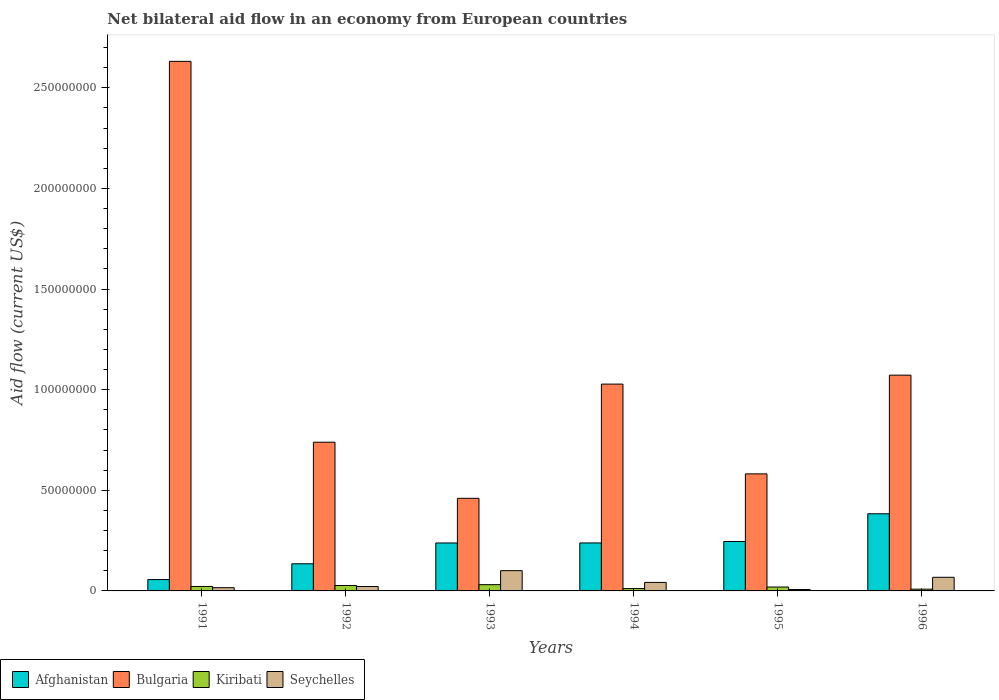How many groups of bars are there?
Your response must be concise. 6. Are the number of bars per tick equal to the number of legend labels?
Your response must be concise. Yes. How many bars are there on the 1st tick from the right?
Your answer should be very brief. 4. What is the label of the 3rd group of bars from the left?
Your answer should be compact. 1993. In how many cases, is the number of bars for a given year not equal to the number of legend labels?
Ensure brevity in your answer.  0. What is the net bilateral aid flow in Kiribati in 1996?
Ensure brevity in your answer.  8.70e+05. Across all years, what is the maximum net bilateral aid flow in Seychelles?
Ensure brevity in your answer.  1.01e+07. Across all years, what is the minimum net bilateral aid flow in Kiribati?
Provide a succinct answer. 8.70e+05. In which year was the net bilateral aid flow in Afghanistan maximum?
Provide a short and direct response. 1996. What is the total net bilateral aid flow in Afghanistan in the graph?
Give a very brief answer. 1.30e+08. What is the difference between the net bilateral aid flow in Afghanistan in 1991 and that in 1993?
Your answer should be very brief. -1.82e+07. What is the difference between the net bilateral aid flow in Seychelles in 1993 and the net bilateral aid flow in Afghanistan in 1994?
Keep it short and to the point. -1.38e+07. What is the average net bilateral aid flow in Kiribati per year?
Make the answer very short. 2.00e+06. In the year 1993, what is the difference between the net bilateral aid flow in Seychelles and net bilateral aid flow in Afghanistan?
Offer a terse response. -1.38e+07. In how many years, is the net bilateral aid flow in Kiribati greater than 40000000 US$?
Offer a terse response. 0. What is the ratio of the net bilateral aid flow in Kiribati in 1991 to that in 1995?
Provide a succinct answer. 1.14. What is the difference between the highest and the second highest net bilateral aid flow in Bulgaria?
Provide a short and direct response. 1.56e+08. What is the difference between the highest and the lowest net bilateral aid flow in Kiribati?
Provide a short and direct response. 2.24e+06. Is the sum of the net bilateral aid flow in Kiribati in 1992 and 1996 greater than the maximum net bilateral aid flow in Afghanistan across all years?
Keep it short and to the point. No. Is it the case that in every year, the sum of the net bilateral aid flow in Afghanistan and net bilateral aid flow in Kiribati is greater than the sum of net bilateral aid flow in Seychelles and net bilateral aid flow in Bulgaria?
Give a very brief answer. No. What does the 1st bar from the left in 1993 represents?
Offer a very short reply. Afghanistan. What does the 3rd bar from the right in 1993 represents?
Give a very brief answer. Bulgaria. How many years are there in the graph?
Keep it short and to the point. 6. What is the difference between two consecutive major ticks on the Y-axis?
Keep it short and to the point. 5.00e+07. What is the title of the graph?
Ensure brevity in your answer.  Net bilateral aid flow in an economy from European countries. What is the label or title of the X-axis?
Offer a very short reply. Years. What is the label or title of the Y-axis?
Provide a short and direct response. Aid flow (current US$). What is the Aid flow (current US$) of Afghanistan in 1991?
Provide a short and direct response. 5.64e+06. What is the Aid flow (current US$) in Bulgaria in 1991?
Provide a short and direct response. 2.63e+08. What is the Aid flow (current US$) of Kiribati in 1991?
Your response must be concise. 2.22e+06. What is the Aid flow (current US$) of Seychelles in 1991?
Provide a succinct answer. 1.61e+06. What is the Aid flow (current US$) in Afghanistan in 1992?
Your response must be concise. 1.35e+07. What is the Aid flow (current US$) in Bulgaria in 1992?
Your answer should be very brief. 7.39e+07. What is the Aid flow (current US$) in Kiribati in 1992?
Give a very brief answer. 2.69e+06. What is the Aid flow (current US$) of Seychelles in 1992?
Your answer should be very brief. 2.19e+06. What is the Aid flow (current US$) of Afghanistan in 1993?
Provide a succinct answer. 2.38e+07. What is the Aid flow (current US$) of Bulgaria in 1993?
Provide a succinct answer. 4.60e+07. What is the Aid flow (current US$) of Kiribati in 1993?
Provide a short and direct response. 3.11e+06. What is the Aid flow (current US$) in Seychelles in 1993?
Provide a succinct answer. 1.01e+07. What is the Aid flow (current US$) of Afghanistan in 1994?
Give a very brief answer. 2.38e+07. What is the Aid flow (current US$) in Bulgaria in 1994?
Provide a short and direct response. 1.03e+08. What is the Aid flow (current US$) of Kiribati in 1994?
Your answer should be very brief. 1.16e+06. What is the Aid flow (current US$) in Seychelles in 1994?
Ensure brevity in your answer.  4.23e+06. What is the Aid flow (current US$) of Afghanistan in 1995?
Give a very brief answer. 2.46e+07. What is the Aid flow (current US$) of Bulgaria in 1995?
Provide a succinct answer. 5.82e+07. What is the Aid flow (current US$) of Kiribati in 1995?
Your response must be concise. 1.94e+06. What is the Aid flow (current US$) in Seychelles in 1995?
Your answer should be compact. 7.10e+05. What is the Aid flow (current US$) in Afghanistan in 1996?
Give a very brief answer. 3.83e+07. What is the Aid flow (current US$) of Bulgaria in 1996?
Ensure brevity in your answer.  1.07e+08. What is the Aid flow (current US$) of Kiribati in 1996?
Your answer should be very brief. 8.70e+05. What is the Aid flow (current US$) in Seychelles in 1996?
Your answer should be very brief. 6.77e+06. Across all years, what is the maximum Aid flow (current US$) in Afghanistan?
Make the answer very short. 3.83e+07. Across all years, what is the maximum Aid flow (current US$) in Bulgaria?
Give a very brief answer. 2.63e+08. Across all years, what is the maximum Aid flow (current US$) in Kiribati?
Provide a succinct answer. 3.11e+06. Across all years, what is the maximum Aid flow (current US$) of Seychelles?
Ensure brevity in your answer.  1.01e+07. Across all years, what is the minimum Aid flow (current US$) of Afghanistan?
Ensure brevity in your answer.  5.64e+06. Across all years, what is the minimum Aid flow (current US$) of Bulgaria?
Your answer should be compact. 4.60e+07. Across all years, what is the minimum Aid flow (current US$) in Kiribati?
Your response must be concise. 8.70e+05. Across all years, what is the minimum Aid flow (current US$) in Seychelles?
Your answer should be compact. 7.10e+05. What is the total Aid flow (current US$) of Afghanistan in the graph?
Provide a short and direct response. 1.30e+08. What is the total Aid flow (current US$) of Bulgaria in the graph?
Ensure brevity in your answer.  6.51e+08. What is the total Aid flow (current US$) of Kiribati in the graph?
Your answer should be very brief. 1.20e+07. What is the total Aid flow (current US$) of Seychelles in the graph?
Give a very brief answer. 2.56e+07. What is the difference between the Aid flow (current US$) of Afghanistan in 1991 and that in 1992?
Ensure brevity in your answer.  -7.84e+06. What is the difference between the Aid flow (current US$) in Bulgaria in 1991 and that in 1992?
Your response must be concise. 1.89e+08. What is the difference between the Aid flow (current US$) in Kiribati in 1991 and that in 1992?
Give a very brief answer. -4.70e+05. What is the difference between the Aid flow (current US$) in Seychelles in 1991 and that in 1992?
Offer a very short reply. -5.80e+05. What is the difference between the Aid flow (current US$) in Afghanistan in 1991 and that in 1993?
Provide a succinct answer. -1.82e+07. What is the difference between the Aid flow (current US$) in Bulgaria in 1991 and that in 1993?
Provide a succinct answer. 2.17e+08. What is the difference between the Aid flow (current US$) of Kiribati in 1991 and that in 1993?
Provide a succinct answer. -8.90e+05. What is the difference between the Aid flow (current US$) in Seychelles in 1991 and that in 1993?
Your answer should be very brief. -8.46e+06. What is the difference between the Aid flow (current US$) in Afghanistan in 1991 and that in 1994?
Give a very brief answer. -1.82e+07. What is the difference between the Aid flow (current US$) of Bulgaria in 1991 and that in 1994?
Provide a short and direct response. 1.60e+08. What is the difference between the Aid flow (current US$) of Kiribati in 1991 and that in 1994?
Make the answer very short. 1.06e+06. What is the difference between the Aid flow (current US$) in Seychelles in 1991 and that in 1994?
Offer a very short reply. -2.62e+06. What is the difference between the Aid flow (current US$) of Afghanistan in 1991 and that in 1995?
Your answer should be compact. -1.89e+07. What is the difference between the Aid flow (current US$) in Bulgaria in 1991 and that in 1995?
Offer a terse response. 2.05e+08. What is the difference between the Aid flow (current US$) in Seychelles in 1991 and that in 1995?
Your response must be concise. 9.00e+05. What is the difference between the Aid flow (current US$) in Afghanistan in 1991 and that in 1996?
Give a very brief answer. -3.27e+07. What is the difference between the Aid flow (current US$) in Bulgaria in 1991 and that in 1996?
Your answer should be compact. 1.56e+08. What is the difference between the Aid flow (current US$) in Kiribati in 1991 and that in 1996?
Offer a terse response. 1.35e+06. What is the difference between the Aid flow (current US$) in Seychelles in 1991 and that in 1996?
Your response must be concise. -5.16e+06. What is the difference between the Aid flow (current US$) in Afghanistan in 1992 and that in 1993?
Your response must be concise. -1.03e+07. What is the difference between the Aid flow (current US$) in Bulgaria in 1992 and that in 1993?
Offer a very short reply. 2.79e+07. What is the difference between the Aid flow (current US$) of Kiribati in 1992 and that in 1993?
Offer a terse response. -4.20e+05. What is the difference between the Aid flow (current US$) of Seychelles in 1992 and that in 1993?
Provide a short and direct response. -7.88e+06. What is the difference between the Aid flow (current US$) in Afghanistan in 1992 and that in 1994?
Make the answer very short. -1.04e+07. What is the difference between the Aid flow (current US$) in Bulgaria in 1992 and that in 1994?
Your response must be concise. -2.89e+07. What is the difference between the Aid flow (current US$) in Kiribati in 1992 and that in 1994?
Ensure brevity in your answer.  1.53e+06. What is the difference between the Aid flow (current US$) of Seychelles in 1992 and that in 1994?
Your answer should be very brief. -2.04e+06. What is the difference between the Aid flow (current US$) of Afghanistan in 1992 and that in 1995?
Your answer should be compact. -1.11e+07. What is the difference between the Aid flow (current US$) in Bulgaria in 1992 and that in 1995?
Ensure brevity in your answer.  1.57e+07. What is the difference between the Aid flow (current US$) of Kiribati in 1992 and that in 1995?
Your answer should be very brief. 7.50e+05. What is the difference between the Aid flow (current US$) in Seychelles in 1992 and that in 1995?
Keep it short and to the point. 1.48e+06. What is the difference between the Aid flow (current US$) in Afghanistan in 1992 and that in 1996?
Offer a terse response. -2.48e+07. What is the difference between the Aid flow (current US$) of Bulgaria in 1992 and that in 1996?
Offer a terse response. -3.33e+07. What is the difference between the Aid flow (current US$) in Kiribati in 1992 and that in 1996?
Offer a very short reply. 1.82e+06. What is the difference between the Aid flow (current US$) of Seychelles in 1992 and that in 1996?
Your response must be concise. -4.58e+06. What is the difference between the Aid flow (current US$) in Bulgaria in 1993 and that in 1994?
Your response must be concise. -5.67e+07. What is the difference between the Aid flow (current US$) of Kiribati in 1993 and that in 1994?
Give a very brief answer. 1.95e+06. What is the difference between the Aid flow (current US$) in Seychelles in 1993 and that in 1994?
Provide a short and direct response. 5.84e+06. What is the difference between the Aid flow (current US$) in Afghanistan in 1993 and that in 1995?
Provide a short and direct response. -7.40e+05. What is the difference between the Aid flow (current US$) in Bulgaria in 1993 and that in 1995?
Ensure brevity in your answer.  -1.21e+07. What is the difference between the Aid flow (current US$) in Kiribati in 1993 and that in 1995?
Keep it short and to the point. 1.17e+06. What is the difference between the Aid flow (current US$) in Seychelles in 1993 and that in 1995?
Make the answer very short. 9.36e+06. What is the difference between the Aid flow (current US$) in Afghanistan in 1993 and that in 1996?
Your answer should be compact. -1.45e+07. What is the difference between the Aid flow (current US$) of Bulgaria in 1993 and that in 1996?
Provide a succinct answer. -6.12e+07. What is the difference between the Aid flow (current US$) in Kiribati in 1993 and that in 1996?
Provide a succinct answer. 2.24e+06. What is the difference between the Aid flow (current US$) of Seychelles in 1993 and that in 1996?
Your answer should be very brief. 3.30e+06. What is the difference between the Aid flow (current US$) in Afghanistan in 1994 and that in 1995?
Make the answer very short. -7.20e+05. What is the difference between the Aid flow (current US$) of Bulgaria in 1994 and that in 1995?
Your response must be concise. 4.46e+07. What is the difference between the Aid flow (current US$) in Kiribati in 1994 and that in 1995?
Keep it short and to the point. -7.80e+05. What is the difference between the Aid flow (current US$) of Seychelles in 1994 and that in 1995?
Provide a short and direct response. 3.52e+06. What is the difference between the Aid flow (current US$) of Afghanistan in 1994 and that in 1996?
Provide a short and direct response. -1.45e+07. What is the difference between the Aid flow (current US$) in Bulgaria in 1994 and that in 1996?
Keep it short and to the point. -4.45e+06. What is the difference between the Aid flow (current US$) in Kiribati in 1994 and that in 1996?
Provide a short and direct response. 2.90e+05. What is the difference between the Aid flow (current US$) of Seychelles in 1994 and that in 1996?
Your answer should be very brief. -2.54e+06. What is the difference between the Aid flow (current US$) of Afghanistan in 1995 and that in 1996?
Make the answer very short. -1.38e+07. What is the difference between the Aid flow (current US$) in Bulgaria in 1995 and that in 1996?
Provide a succinct answer. -4.91e+07. What is the difference between the Aid flow (current US$) of Kiribati in 1995 and that in 1996?
Keep it short and to the point. 1.07e+06. What is the difference between the Aid flow (current US$) of Seychelles in 1995 and that in 1996?
Offer a terse response. -6.06e+06. What is the difference between the Aid flow (current US$) of Afghanistan in 1991 and the Aid flow (current US$) of Bulgaria in 1992?
Provide a succinct answer. -6.82e+07. What is the difference between the Aid flow (current US$) in Afghanistan in 1991 and the Aid flow (current US$) in Kiribati in 1992?
Provide a short and direct response. 2.95e+06. What is the difference between the Aid flow (current US$) of Afghanistan in 1991 and the Aid flow (current US$) of Seychelles in 1992?
Provide a succinct answer. 3.45e+06. What is the difference between the Aid flow (current US$) of Bulgaria in 1991 and the Aid flow (current US$) of Kiribati in 1992?
Offer a very short reply. 2.60e+08. What is the difference between the Aid flow (current US$) in Bulgaria in 1991 and the Aid flow (current US$) in Seychelles in 1992?
Provide a short and direct response. 2.61e+08. What is the difference between the Aid flow (current US$) of Kiribati in 1991 and the Aid flow (current US$) of Seychelles in 1992?
Make the answer very short. 3.00e+04. What is the difference between the Aid flow (current US$) in Afghanistan in 1991 and the Aid flow (current US$) in Bulgaria in 1993?
Give a very brief answer. -4.04e+07. What is the difference between the Aid flow (current US$) in Afghanistan in 1991 and the Aid flow (current US$) in Kiribati in 1993?
Offer a terse response. 2.53e+06. What is the difference between the Aid flow (current US$) in Afghanistan in 1991 and the Aid flow (current US$) in Seychelles in 1993?
Make the answer very short. -4.43e+06. What is the difference between the Aid flow (current US$) in Bulgaria in 1991 and the Aid flow (current US$) in Kiribati in 1993?
Make the answer very short. 2.60e+08. What is the difference between the Aid flow (current US$) in Bulgaria in 1991 and the Aid flow (current US$) in Seychelles in 1993?
Your response must be concise. 2.53e+08. What is the difference between the Aid flow (current US$) of Kiribati in 1991 and the Aid flow (current US$) of Seychelles in 1993?
Your answer should be compact. -7.85e+06. What is the difference between the Aid flow (current US$) of Afghanistan in 1991 and the Aid flow (current US$) of Bulgaria in 1994?
Ensure brevity in your answer.  -9.71e+07. What is the difference between the Aid flow (current US$) in Afghanistan in 1991 and the Aid flow (current US$) in Kiribati in 1994?
Provide a short and direct response. 4.48e+06. What is the difference between the Aid flow (current US$) in Afghanistan in 1991 and the Aid flow (current US$) in Seychelles in 1994?
Ensure brevity in your answer.  1.41e+06. What is the difference between the Aid flow (current US$) of Bulgaria in 1991 and the Aid flow (current US$) of Kiribati in 1994?
Ensure brevity in your answer.  2.62e+08. What is the difference between the Aid flow (current US$) in Bulgaria in 1991 and the Aid flow (current US$) in Seychelles in 1994?
Give a very brief answer. 2.59e+08. What is the difference between the Aid flow (current US$) in Kiribati in 1991 and the Aid flow (current US$) in Seychelles in 1994?
Make the answer very short. -2.01e+06. What is the difference between the Aid flow (current US$) in Afghanistan in 1991 and the Aid flow (current US$) in Bulgaria in 1995?
Provide a succinct answer. -5.25e+07. What is the difference between the Aid flow (current US$) in Afghanistan in 1991 and the Aid flow (current US$) in Kiribati in 1995?
Keep it short and to the point. 3.70e+06. What is the difference between the Aid flow (current US$) of Afghanistan in 1991 and the Aid flow (current US$) of Seychelles in 1995?
Make the answer very short. 4.93e+06. What is the difference between the Aid flow (current US$) in Bulgaria in 1991 and the Aid flow (current US$) in Kiribati in 1995?
Offer a terse response. 2.61e+08. What is the difference between the Aid flow (current US$) in Bulgaria in 1991 and the Aid flow (current US$) in Seychelles in 1995?
Provide a succinct answer. 2.62e+08. What is the difference between the Aid flow (current US$) in Kiribati in 1991 and the Aid flow (current US$) in Seychelles in 1995?
Provide a short and direct response. 1.51e+06. What is the difference between the Aid flow (current US$) of Afghanistan in 1991 and the Aid flow (current US$) of Bulgaria in 1996?
Ensure brevity in your answer.  -1.02e+08. What is the difference between the Aid flow (current US$) of Afghanistan in 1991 and the Aid flow (current US$) of Kiribati in 1996?
Provide a short and direct response. 4.77e+06. What is the difference between the Aid flow (current US$) in Afghanistan in 1991 and the Aid flow (current US$) in Seychelles in 1996?
Make the answer very short. -1.13e+06. What is the difference between the Aid flow (current US$) of Bulgaria in 1991 and the Aid flow (current US$) of Kiribati in 1996?
Keep it short and to the point. 2.62e+08. What is the difference between the Aid flow (current US$) in Bulgaria in 1991 and the Aid flow (current US$) in Seychelles in 1996?
Provide a succinct answer. 2.56e+08. What is the difference between the Aid flow (current US$) of Kiribati in 1991 and the Aid flow (current US$) of Seychelles in 1996?
Offer a terse response. -4.55e+06. What is the difference between the Aid flow (current US$) in Afghanistan in 1992 and the Aid flow (current US$) in Bulgaria in 1993?
Your answer should be very brief. -3.25e+07. What is the difference between the Aid flow (current US$) of Afghanistan in 1992 and the Aid flow (current US$) of Kiribati in 1993?
Provide a short and direct response. 1.04e+07. What is the difference between the Aid flow (current US$) in Afghanistan in 1992 and the Aid flow (current US$) in Seychelles in 1993?
Ensure brevity in your answer.  3.41e+06. What is the difference between the Aid flow (current US$) in Bulgaria in 1992 and the Aid flow (current US$) in Kiribati in 1993?
Your answer should be compact. 7.08e+07. What is the difference between the Aid flow (current US$) in Bulgaria in 1992 and the Aid flow (current US$) in Seychelles in 1993?
Keep it short and to the point. 6.38e+07. What is the difference between the Aid flow (current US$) of Kiribati in 1992 and the Aid flow (current US$) of Seychelles in 1993?
Offer a terse response. -7.38e+06. What is the difference between the Aid flow (current US$) of Afghanistan in 1992 and the Aid flow (current US$) of Bulgaria in 1994?
Provide a short and direct response. -8.93e+07. What is the difference between the Aid flow (current US$) of Afghanistan in 1992 and the Aid flow (current US$) of Kiribati in 1994?
Your answer should be compact. 1.23e+07. What is the difference between the Aid flow (current US$) in Afghanistan in 1992 and the Aid flow (current US$) in Seychelles in 1994?
Provide a succinct answer. 9.25e+06. What is the difference between the Aid flow (current US$) in Bulgaria in 1992 and the Aid flow (current US$) in Kiribati in 1994?
Your response must be concise. 7.27e+07. What is the difference between the Aid flow (current US$) in Bulgaria in 1992 and the Aid flow (current US$) in Seychelles in 1994?
Offer a very short reply. 6.97e+07. What is the difference between the Aid flow (current US$) of Kiribati in 1992 and the Aid flow (current US$) of Seychelles in 1994?
Provide a short and direct response. -1.54e+06. What is the difference between the Aid flow (current US$) in Afghanistan in 1992 and the Aid flow (current US$) in Bulgaria in 1995?
Ensure brevity in your answer.  -4.47e+07. What is the difference between the Aid flow (current US$) in Afghanistan in 1992 and the Aid flow (current US$) in Kiribati in 1995?
Provide a succinct answer. 1.15e+07. What is the difference between the Aid flow (current US$) in Afghanistan in 1992 and the Aid flow (current US$) in Seychelles in 1995?
Give a very brief answer. 1.28e+07. What is the difference between the Aid flow (current US$) in Bulgaria in 1992 and the Aid flow (current US$) in Kiribati in 1995?
Give a very brief answer. 7.20e+07. What is the difference between the Aid flow (current US$) of Bulgaria in 1992 and the Aid flow (current US$) of Seychelles in 1995?
Your answer should be compact. 7.32e+07. What is the difference between the Aid flow (current US$) of Kiribati in 1992 and the Aid flow (current US$) of Seychelles in 1995?
Your answer should be very brief. 1.98e+06. What is the difference between the Aid flow (current US$) in Afghanistan in 1992 and the Aid flow (current US$) in Bulgaria in 1996?
Ensure brevity in your answer.  -9.37e+07. What is the difference between the Aid flow (current US$) of Afghanistan in 1992 and the Aid flow (current US$) of Kiribati in 1996?
Your answer should be very brief. 1.26e+07. What is the difference between the Aid flow (current US$) of Afghanistan in 1992 and the Aid flow (current US$) of Seychelles in 1996?
Offer a terse response. 6.71e+06. What is the difference between the Aid flow (current US$) in Bulgaria in 1992 and the Aid flow (current US$) in Kiribati in 1996?
Provide a short and direct response. 7.30e+07. What is the difference between the Aid flow (current US$) in Bulgaria in 1992 and the Aid flow (current US$) in Seychelles in 1996?
Your response must be concise. 6.71e+07. What is the difference between the Aid flow (current US$) in Kiribati in 1992 and the Aid flow (current US$) in Seychelles in 1996?
Your answer should be very brief. -4.08e+06. What is the difference between the Aid flow (current US$) of Afghanistan in 1993 and the Aid flow (current US$) of Bulgaria in 1994?
Offer a terse response. -7.89e+07. What is the difference between the Aid flow (current US$) of Afghanistan in 1993 and the Aid flow (current US$) of Kiribati in 1994?
Your response must be concise. 2.27e+07. What is the difference between the Aid flow (current US$) of Afghanistan in 1993 and the Aid flow (current US$) of Seychelles in 1994?
Your answer should be very brief. 1.96e+07. What is the difference between the Aid flow (current US$) in Bulgaria in 1993 and the Aid flow (current US$) in Kiribati in 1994?
Ensure brevity in your answer.  4.49e+07. What is the difference between the Aid flow (current US$) in Bulgaria in 1993 and the Aid flow (current US$) in Seychelles in 1994?
Your answer should be compact. 4.18e+07. What is the difference between the Aid flow (current US$) in Kiribati in 1993 and the Aid flow (current US$) in Seychelles in 1994?
Your answer should be very brief. -1.12e+06. What is the difference between the Aid flow (current US$) of Afghanistan in 1993 and the Aid flow (current US$) of Bulgaria in 1995?
Provide a succinct answer. -3.43e+07. What is the difference between the Aid flow (current US$) of Afghanistan in 1993 and the Aid flow (current US$) of Kiribati in 1995?
Provide a short and direct response. 2.19e+07. What is the difference between the Aid flow (current US$) in Afghanistan in 1993 and the Aid flow (current US$) in Seychelles in 1995?
Make the answer very short. 2.31e+07. What is the difference between the Aid flow (current US$) of Bulgaria in 1993 and the Aid flow (current US$) of Kiribati in 1995?
Provide a succinct answer. 4.41e+07. What is the difference between the Aid flow (current US$) in Bulgaria in 1993 and the Aid flow (current US$) in Seychelles in 1995?
Your response must be concise. 4.53e+07. What is the difference between the Aid flow (current US$) in Kiribati in 1993 and the Aid flow (current US$) in Seychelles in 1995?
Your answer should be very brief. 2.40e+06. What is the difference between the Aid flow (current US$) in Afghanistan in 1993 and the Aid flow (current US$) in Bulgaria in 1996?
Offer a terse response. -8.34e+07. What is the difference between the Aid flow (current US$) in Afghanistan in 1993 and the Aid flow (current US$) in Kiribati in 1996?
Offer a terse response. 2.30e+07. What is the difference between the Aid flow (current US$) in Afghanistan in 1993 and the Aid flow (current US$) in Seychelles in 1996?
Offer a very short reply. 1.70e+07. What is the difference between the Aid flow (current US$) of Bulgaria in 1993 and the Aid flow (current US$) of Kiribati in 1996?
Offer a terse response. 4.52e+07. What is the difference between the Aid flow (current US$) in Bulgaria in 1993 and the Aid flow (current US$) in Seychelles in 1996?
Make the answer very short. 3.92e+07. What is the difference between the Aid flow (current US$) of Kiribati in 1993 and the Aid flow (current US$) of Seychelles in 1996?
Provide a succinct answer. -3.66e+06. What is the difference between the Aid flow (current US$) in Afghanistan in 1994 and the Aid flow (current US$) in Bulgaria in 1995?
Offer a terse response. -3.43e+07. What is the difference between the Aid flow (current US$) of Afghanistan in 1994 and the Aid flow (current US$) of Kiribati in 1995?
Offer a very short reply. 2.19e+07. What is the difference between the Aid flow (current US$) of Afghanistan in 1994 and the Aid flow (current US$) of Seychelles in 1995?
Ensure brevity in your answer.  2.31e+07. What is the difference between the Aid flow (current US$) of Bulgaria in 1994 and the Aid flow (current US$) of Kiribati in 1995?
Your answer should be compact. 1.01e+08. What is the difference between the Aid flow (current US$) of Bulgaria in 1994 and the Aid flow (current US$) of Seychelles in 1995?
Your answer should be very brief. 1.02e+08. What is the difference between the Aid flow (current US$) of Afghanistan in 1994 and the Aid flow (current US$) of Bulgaria in 1996?
Provide a short and direct response. -8.34e+07. What is the difference between the Aid flow (current US$) of Afghanistan in 1994 and the Aid flow (current US$) of Kiribati in 1996?
Your answer should be compact. 2.30e+07. What is the difference between the Aid flow (current US$) in Afghanistan in 1994 and the Aid flow (current US$) in Seychelles in 1996?
Make the answer very short. 1.71e+07. What is the difference between the Aid flow (current US$) in Bulgaria in 1994 and the Aid flow (current US$) in Kiribati in 1996?
Offer a terse response. 1.02e+08. What is the difference between the Aid flow (current US$) in Bulgaria in 1994 and the Aid flow (current US$) in Seychelles in 1996?
Provide a succinct answer. 9.60e+07. What is the difference between the Aid flow (current US$) of Kiribati in 1994 and the Aid flow (current US$) of Seychelles in 1996?
Provide a short and direct response. -5.61e+06. What is the difference between the Aid flow (current US$) of Afghanistan in 1995 and the Aid flow (current US$) of Bulgaria in 1996?
Your response must be concise. -8.26e+07. What is the difference between the Aid flow (current US$) of Afghanistan in 1995 and the Aid flow (current US$) of Kiribati in 1996?
Keep it short and to the point. 2.37e+07. What is the difference between the Aid flow (current US$) in Afghanistan in 1995 and the Aid flow (current US$) in Seychelles in 1996?
Provide a succinct answer. 1.78e+07. What is the difference between the Aid flow (current US$) in Bulgaria in 1995 and the Aid flow (current US$) in Kiribati in 1996?
Your answer should be compact. 5.73e+07. What is the difference between the Aid flow (current US$) of Bulgaria in 1995 and the Aid flow (current US$) of Seychelles in 1996?
Give a very brief answer. 5.14e+07. What is the difference between the Aid flow (current US$) in Kiribati in 1995 and the Aid flow (current US$) in Seychelles in 1996?
Give a very brief answer. -4.83e+06. What is the average Aid flow (current US$) in Afghanistan per year?
Give a very brief answer. 2.16e+07. What is the average Aid flow (current US$) of Bulgaria per year?
Ensure brevity in your answer.  1.09e+08. What is the average Aid flow (current US$) of Kiribati per year?
Your response must be concise. 2.00e+06. What is the average Aid flow (current US$) of Seychelles per year?
Make the answer very short. 4.26e+06. In the year 1991, what is the difference between the Aid flow (current US$) in Afghanistan and Aid flow (current US$) in Bulgaria?
Offer a terse response. -2.57e+08. In the year 1991, what is the difference between the Aid flow (current US$) in Afghanistan and Aid flow (current US$) in Kiribati?
Provide a short and direct response. 3.42e+06. In the year 1991, what is the difference between the Aid flow (current US$) in Afghanistan and Aid flow (current US$) in Seychelles?
Give a very brief answer. 4.03e+06. In the year 1991, what is the difference between the Aid flow (current US$) of Bulgaria and Aid flow (current US$) of Kiribati?
Keep it short and to the point. 2.61e+08. In the year 1991, what is the difference between the Aid flow (current US$) of Bulgaria and Aid flow (current US$) of Seychelles?
Make the answer very short. 2.62e+08. In the year 1992, what is the difference between the Aid flow (current US$) of Afghanistan and Aid flow (current US$) of Bulgaria?
Make the answer very short. -6.04e+07. In the year 1992, what is the difference between the Aid flow (current US$) of Afghanistan and Aid flow (current US$) of Kiribati?
Offer a terse response. 1.08e+07. In the year 1992, what is the difference between the Aid flow (current US$) in Afghanistan and Aid flow (current US$) in Seychelles?
Your answer should be compact. 1.13e+07. In the year 1992, what is the difference between the Aid flow (current US$) in Bulgaria and Aid flow (current US$) in Kiribati?
Provide a short and direct response. 7.12e+07. In the year 1992, what is the difference between the Aid flow (current US$) of Bulgaria and Aid flow (current US$) of Seychelles?
Provide a short and direct response. 7.17e+07. In the year 1992, what is the difference between the Aid flow (current US$) of Kiribati and Aid flow (current US$) of Seychelles?
Give a very brief answer. 5.00e+05. In the year 1993, what is the difference between the Aid flow (current US$) in Afghanistan and Aid flow (current US$) in Bulgaria?
Provide a succinct answer. -2.22e+07. In the year 1993, what is the difference between the Aid flow (current US$) in Afghanistan and Aid flow (current US$) in Kiribati?
Make the answer very short. 2.07e+07. In the year 1993, what is the difference between the Aid flow (current US$) of Afghanistan and Aid flow (current US$) of Seychelles?
Make the answer very short. 1.38e+07. In the year 1993, what is the difference between the Aid flow (current US$) of Bulgaria and Aid flow (current US$) of Kiribati?
Make the answer very short. 4.29e+07. In the year 1993, what is the difference between the Aid flow (current US$) in Bulgaria and Aid flow (current US$) in Seychelles?
Provide a short and direct response. 3.60e+07. In the year 1993, what is the difference between the Aid flow (current US$) of Kiribati and Aid flow (current US$) of Seychelles?
Give a very brief answer. -6.96e+06. In the year 1994, what is the difference between the Aid flow (current US$) in Afghanistan and Aid flow (current US$) in Bulgaria?
Your answer should be very brief. -7.89e+07. In the year 1994, what is the difference between the Aid flow (current US$) of Afghanistan and Aid flow (current US$) of Kiribati?
Provide a short and direct response. 2.27e+07. In the year 1994, what is the difference between the Aid flow (current US$) of Afghanistan and Aid flow (current US$) of Seychelles?
Your answer should be very brief. 1.96e+07. In the year 1994, what is the difference between the Aid flow (current US$) of Bulgaria and Aid flow (current US$) of Kiribati?
Your answer should be compact. 1.02e+08. In the year 1994, what is the difference between the Aid flow (current US$) in Bulgaria and Aid flow (current US$) in Seychelles?
Provide a short and direct response. 9.85e+07. In the year 1994, what is the difference between the Aid flow (current US$) in Kiribati and Aid flow (current US$) in Seychelles?
Provide a short and direct response. -3.07e+06. In the year 1995, what is the difference between the Aid flow (current US$) of Afghanistan and Aid flow (current US$) of Bulgaria?
Make the answer very short. -3.36e+07. In the year 1995, what is the difference between the Aid flow (current US$) in Afghanistan and Aid flow (current US$) in Kiribati?
Make the answer very short. 2.26e+07. In the year 1995, what is the difference between the Aid flow (current US$) in Afghanistan and Aid flow (current US$) in Seychelles?
Give a very brief answer. 2.38e+07. In the year 1995, what is the difference between the Aid flow (current US$) in Bulgaria and Aid flow (current US$) in Kiribati?
Provide a succinct answer. 5.62e+07. In the year 1995, what is the difference between the Aid flow (current US$) in Bulgaria and Aid flow (current US$) in Seychelles?
Your response must be concise. 5.74e+07. In the year 1995, what is the difference between the Aid flow (current US$) of Kiribati and Aid flow (current US$) of Seychelles?
Your answer should be compact. 1.23e+06. In the year 1996, what is the difference between the Aid flow (current US$) in Afghanistan and Aid flow (current US$) in Bulgaria?
Your answer should be compact. -6.89e+07. In the year 1996, what is the difference between the Aid flow (current US$) in Afghanistan and Aid flow (current US$) in Kiribati?
Your response must be concise. 3.75e+07. In the year 1996, what is the difference between the Aid flow (current US$) in Afghanistan and Aid flow (current US$) in Seychelles?
Give a very brief answer. 3.16e+07. In the year 1996, what is the difference between the Aid flow (current US$) in Bulgaria and Aid flow (current US$) in Kiribati?
Provide a short and direct response. 1.06e+08. In the year 1996, what is the difference between the Aid flow (current US$) in Bulgaria and Aid flow (current US$) in Seychelles?
Your answer should be compact. 1.00e+08. In the year 1996, what is the difference between the Aid flow (current US$) in Kiribati and Aid flow (current US$) in Seychelles?
Provide a succinct answer. -5.90e+06. What is the ratio of the Aid flow (current US$) in Afghanistan in 1991 to that in 1992?
Ensure brevity in your answer.  0.42. What is the ratio of the Aid flow (current US$) in Bulgaria in 1991 to that in 1992?
Offer a terse response. 3.56. What is the ratio of the Aid flow (current US$) of Kiribati in 1991 to that in 1992?
Offer a very short reply. 0.83. What is the ratio of the Aid flow (current US$) of Seychelles in 1991 to that in 1992?
Make the answer very short. 0.74. What is the ratio of the Aid flow (current US$) in Afghanistan in 1991 to that in 1993?
Offer a very short reply. 0.24. What is the ratio of the Aid flow (current US$) of Bulgaria in 1991 to that in 1993?
Provide a short and direct response. 5.72. What is the ratio of the Aid flow (current US$) of Kiribati in 1991 to that in 1993?
Your response must be concise. 0.71. What is the ratio of the Aid flow (current US$) of Seychelles in 1991 to that in 1993?
Offer a very short reply. 0.16. What is the ratio of the Aid flow (current US$) in Afghanistan in 1991 to that in 1994?
Provide a short and direct response. 0.24. What is the ratio of the Aid flow (current US$) of Bulgaria in 1991 to that in 1994?
Your response must be concise. 2.56. What is the ratio of the Aid flow (current US$) of Kiribati in 1991 to that in 1994?
Keep it short and to the point. 1.91. What is the ratio of the Aid flow (current US$) of Seychelles in 1991 to that in 1994?
Offer a very short reply. 0.38. What is the ratio of the Aid flow (current US$) of Afghanistan in 1991 to that in 1995?
Your answer should be very brief. 0.23. What is the ratio of the Aid flow (current US$) in Bulgaria in 1991 to that in 1995?
Offer a terse response. 4.52. What is the ratio of the Aid flow (current US$) in Kiribati in 1991 to that in 1995?
Make the answer very short. 1.14. What is the ratio of the Aid flow (current US$) in Seychelles in 1991 to that in 1995?
Your response must be concise. 2.27. What is the ratio of the Aid flow (current US$) of Afghanistan in 1991 to that in 1996?
Ensure brevity in your answer.  0.15. What is the ratio of the Aid flow (current US$) in Bulgaria in 1991 to that in 1996?
Ensure brevity in your answer.  2.45. What is the ratio of the Aid flow (current US$) of Kiribati in 1991 to that in 1996?
Your answer should be very brief. 2.55. What is the ratio of the Aid flow (current US$) of Seychelles in 1991 to that in 1996?
Your answer should be compact. 0.24. What is the ratio of the Aid flow (current US$) in Afghanistan in 1992 to that in 1993?
Offer a terse response. 0.57. What is the ratio of the Aid flow (current US$) in Bulgaria in 1992 to that in 1993?
Offer a terse response. 1.61. What is the ratio of the Aid flow (current US$) in Kiribati in 1992 to that in 1993?
Offer a terse response. 0.86. What is the ratio of the Aid flow (current US$) of Seychelles in 1992 to that in 1993?
Make the answer very short. 0.22. What is the ratio of the Aid flow (current US$) in Afghanistan in 1992 to that in 1994?
Give a very brief answer. 0.57. What is the ratio of the Aid flow (current US$) in Bulgaria in 1992 to that in 1994?
Provide a succinct answer. 0.72. What is the ratio of the Aid flow (current US$) of Kiribati in 1992 to that in 1994?
Ensure brevity in your answer.  2.32. What is the ratio of the Aid flow (current US$) of Seychelles in 1992 to that in 1994?
Keep it short and to the point. 0.52. What is the ratio of the Aid flow (current US$) in Afghanistan in 1992 to that in 1995?
Offer a terse response. 0.55. What is the ratio of the Aid flow (current US$) in Bulgaria in 1992 to that in 1995?
Your answer should be very brief. 1.27. What is the ratio of the Aid flow (current US$) of Kiribati in 1992 to that in 1995?
Provide a short and direct response. 1.39. What is the ratio of the Aid flow (current US$) in Seychelles in 1992 to that in 1995?
Your answer should be compact. 3.08. What is the ratio of the Aid flow (current US$) of Afghanistan in 1992 to that in 1996?
Ensure brevity in your answer.  0.35. What is the ratio of the Aid flow (current US$) in Bulgaria in 1992 to that in 1996?
Ensure brevity in your answer.  0.69. What is the ratio of the Aid flow (current US$) in Kiribati in 1992 to that in 1996?
Your answer should be compact. 3.09. What is the ratio of the Aid flow (current US$) in Seychelles in 1992 to that in 1996?
Keep it short and to the point. 0.32. What is the ratio of the Aid flow (current US$) in Bulgaria in 1993 to that in 1994?
Provide a short and direct response. 0.45. What is the ratio of the Aid flow (current US$) of Kiribati in 1993 to that in 1994?
Keep it short and to the point. 2.68. What is the ratio of the Aid flow (current US$) in Seychelles in 1993 to that in 1994?
Offer a very short reply. 2.38. What is the ratio of the Aid flow (current US$) in Afghanistan in 1993 to that in 1995?
Your response must be concise. 0.97. What is the ratio of the Aid flow (current US$) in Bulgaria in 1993 to that in 1995?
Give a very brief answer. 0.79. What is the ratio of the Aid flow (current US$) in Kiribati in 1993 to that in 1995?
Offer a terse response. 1.6. What is the ratio of the Aid flow (current US$) in Seychelles in 1993 to that in 1995?
Your answer should be very brief. 14.18. What is the ratio of the Aid flow (current US$) of Afghanistan in 1993 to that in 1996?
Your answer should be very brief. 0.62. What is the ratio of the Aid flow (current US$) in Bulgaria in 1993 to that in 1996?
Your answer should be very brief. 0.43. What is the ratio of the Aid flow (current US$) of Kiribati in 1993 to that in 1996?
Offer a terse response. 3.57. What is the ratio of the Aid flow (current US$) of Seychelles in 1993 to that in 1996?
Offer a terse response. 1.49. What is the ratio of the Aid flow (current US$) of Afghanistan in 1994 to that in 1995?
Keep it short and to the point. 0.97. What is the ratio of the Aid flow (current US$) in Bulgaria in 1994 to that in 1995?
Make the answer very short. 1.77. What is the ratio of the Aid flow (current US$) in Kiribati in 1994 to that in 1995?
Your response must be concise. 0.6. What is the ratio of the Aid flow (current US$) in Seychelles in 1994 to that in 1995?
Provide a short and direct response. 5.96. What is the ratio of the Aid flow (current US$) of Afghanistan in 1994 to that in 1996?
Provide a short and direct response. 0.62. What is the ratio of the Aid flow (current US$) in Bulgaria in 1994 to that in 1996?
Ensure brevity in your answer.  0.96. What is the ratio of the Aid flow (current US$) of Kiribati in 1994 to that in 1996?
Your answer should be very brief. 1.33. What is the ratio of the Aid flow (current US$) in Seychelles in 1994 to that in 1996?
Provide a short and direct response. 0.62. What is the ratio of the Aid flow (current US$) of Afghanistan in 1995 to that in 1996?
Your answer should be compact. 0.64. What is the ratio of the Aid flow (current US$) of Bulgaria in 1995 to that in 1996?
Provide a succinct answer. 0.54. What is the ratio of the Aid flow (current US$) in Kiribati in 1995 to that in 1996?
Make the answer very short. 2.23. What is the ratio of the Aid flow (current US$) in Seychelles in 1995 to that in 1996?
Make the answer very short. 0.1. What is the difference between the highest and the second highest Aid flow (current US$) of Afghanistan?
Ensure brevity in your answer.  1.38e+07. What is the difference between the highest and the second highest Aid flow (current US$) of Bulgaria?
Offer a very short reply. 1.56e+08. What is the difference between the highest and the second highest Aid flow (current US$) of Seychelles?
Your answer should be very brief. 3.30e+06. What is the difference between the highest and the lowest Aid flow (current US$) in Afghanistan?
Provide a short and direct response. 3.27e+07. What is the difference between the highest and the lowest Aid flow (current US$) in Bulgaria?
Keep it short and to the point. 2.17e+08. What is the difference between the highest and the lowest Aid flow (current US$) of Kiribati?
Your response must be concise. 2.24e+06. What is the difference between the highest and the lowest Aid flow (current US$) of Seychelles?
Provide a succinct answer. 9.36e+06. 